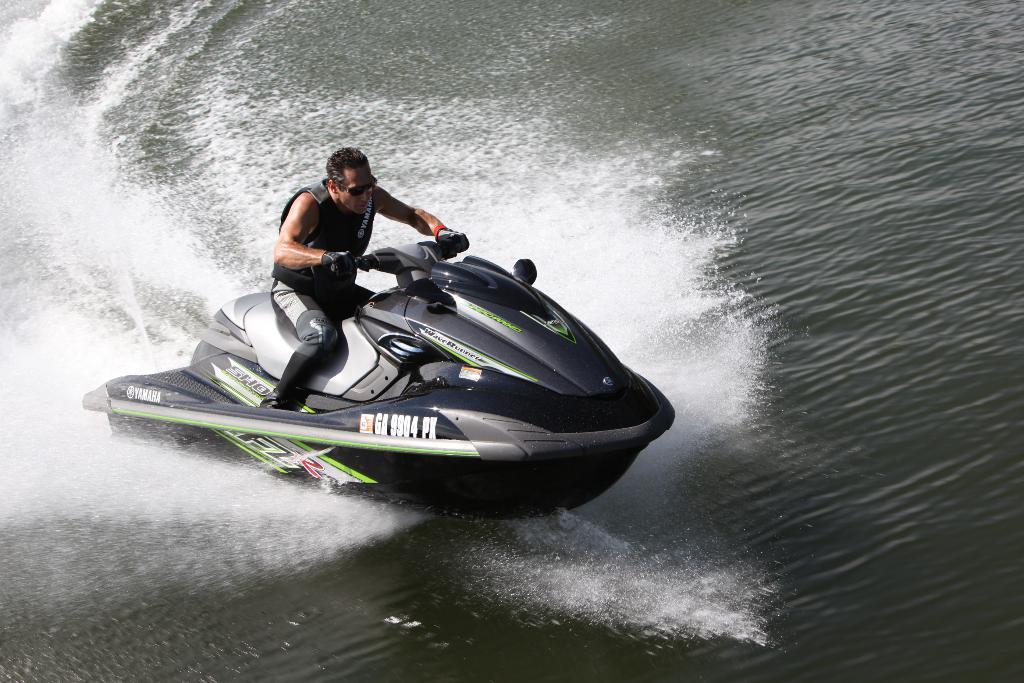Can you describe this image briefly? In the picture I can see a man is sitting on a motor boat. The motor boat is on the water. 